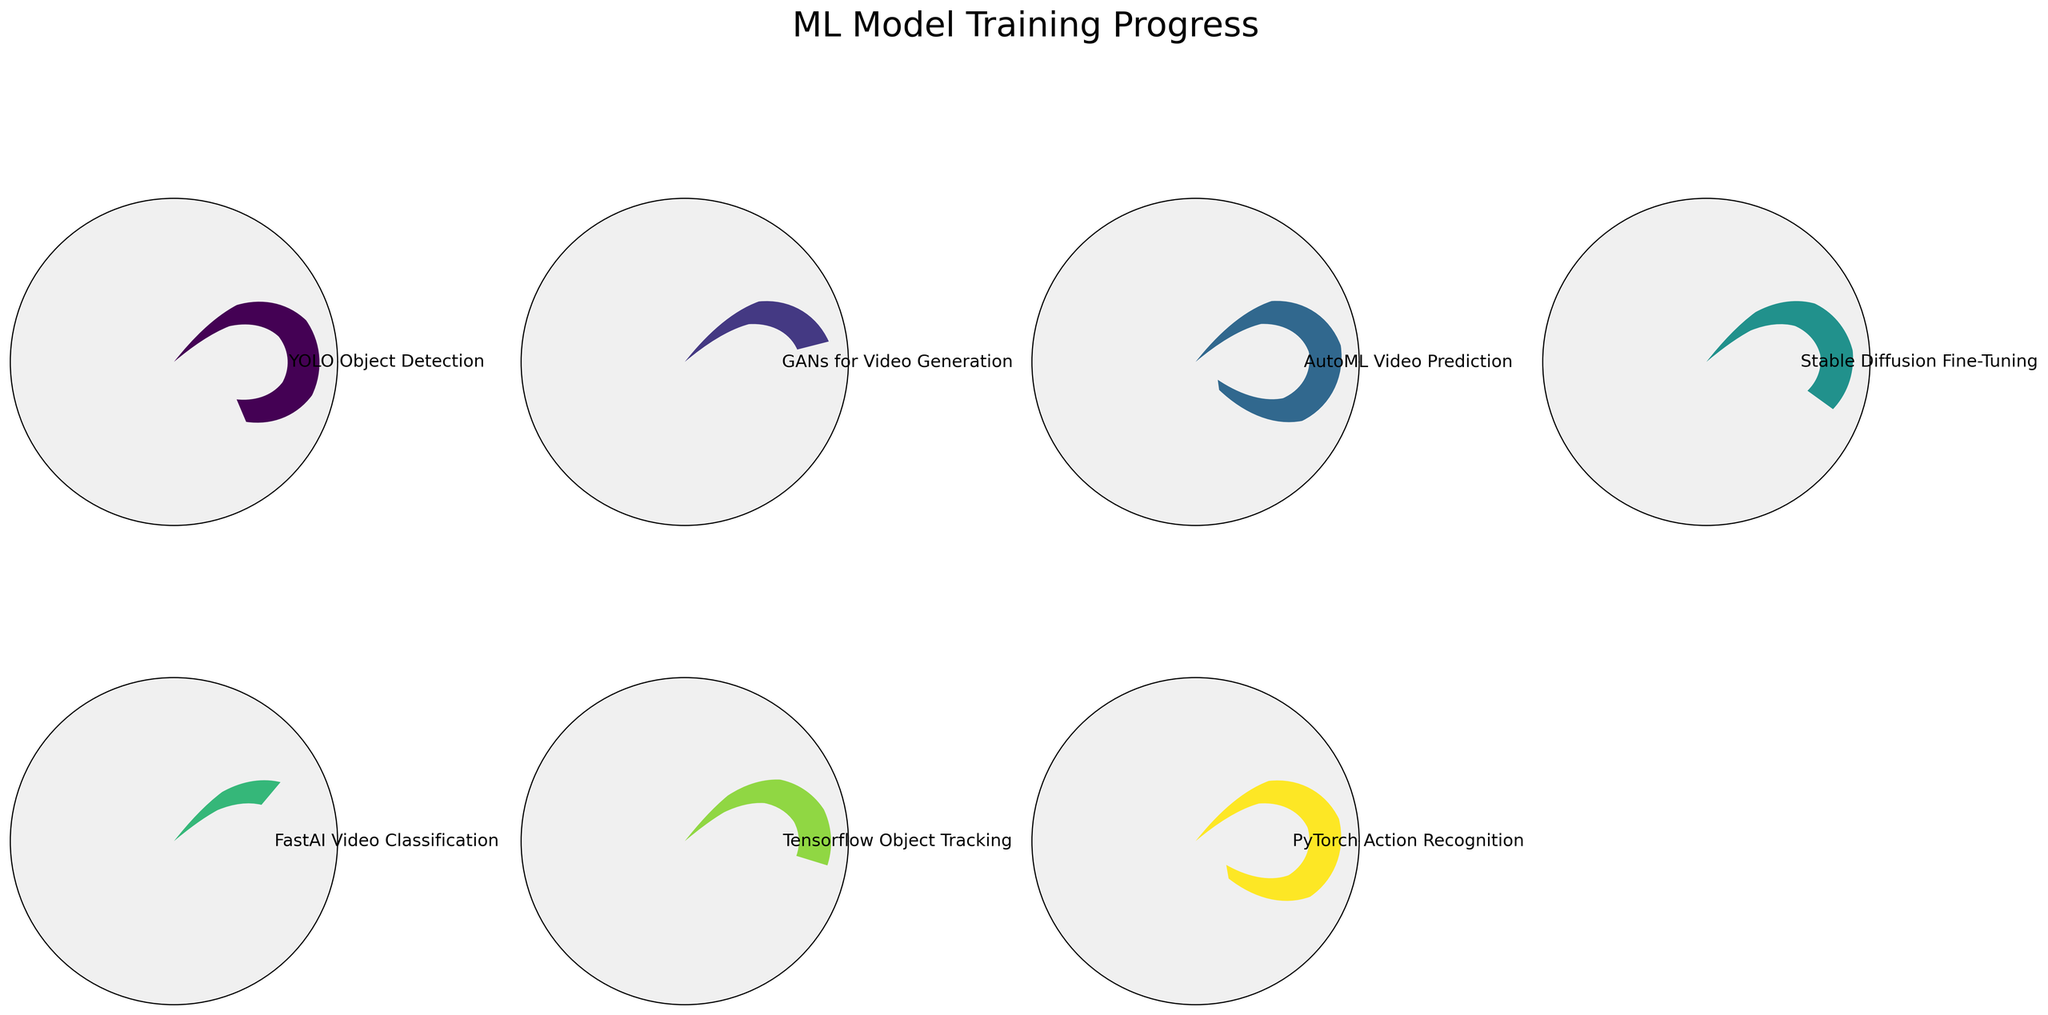What is the progress percentage of the YOLO Object Detection model? The gauge chart for the YOLO Object Detection model shows "78%" underneath the gauge.
Answer: 78% Which model has the highest percentage of completion? By examining each gauge chart, the AutoML Video Prediction model has the highest value at "92%".
Answer: AutoML Video Prediction How many models have a training progress greater than 50%? Counting the gauges with a progress percentage greater than 50, we have YOLO Object Detection, GANs for Video Generation, Stable Diffusion Fine-Tuning, Tensorflow Object Tracking, PyTorch Action Recognition, totaling 5 models.
Answer: 5 models What is the difference in training progress between FastAI Video Classification and AutoML Video Prediction? AutoML Video Prediction has 92%, and FastAI Video Classification has 31%. The difference is 92% - 31% = 61%.
Answer: 61% Which model has the lowest percentage completion? By observing the progress values, FastAI Video Classification shows the lowest completion at "31%".
Answer: FastAI Video Classification What is the average training progress across all models? Summing the percentages (78 + 45 + 92 + 63 + 31 + 56 + 89) gives 454. Dividing by 7 models results in an average of approximately 64.86%.
Answer: ~64.86% Is the training progress of Tensorflow Object Tracking closer to that of GANs for Video Generation or FastAI Video Classification? Tensorflow Object Tracking has 56%, GANs for Video Generation has 45%, and FastAI Video Classification has 31%. The difference is 56 - 45 = 11 for Tensorflow and GANs vs. 56 - 31 = 25 for Tensorflow and FastAI, making it closer to GANs for Video Generation.
Answer: GANs for Video Generation How many models have a training progress visible in the figure? There are a total of 7 gauge charts, one for each model, represented in the figure.
Answer: 7 models By what percentage does PyTorch Action Recognition exceed Stable Diffusion Fine-Tuning in training progress? PyTorch Action Recognition is at 89%, and Stable Diffusion Fine-Tuning is at 63%. The difference is 89% - 63% = 26%.
Answer: 26% Which models have a progress percentage between 50% and 80% inclusive? The models falling within this range are YOLO Object Detection (78%), Stable Diffusion Fine-Tuning (63%), and Tensorflow Object Tracking (56%).
Answer: YOLO Object Detection, Stable Diffusion Fine-Tuning, Tensorflow Object Tracking 